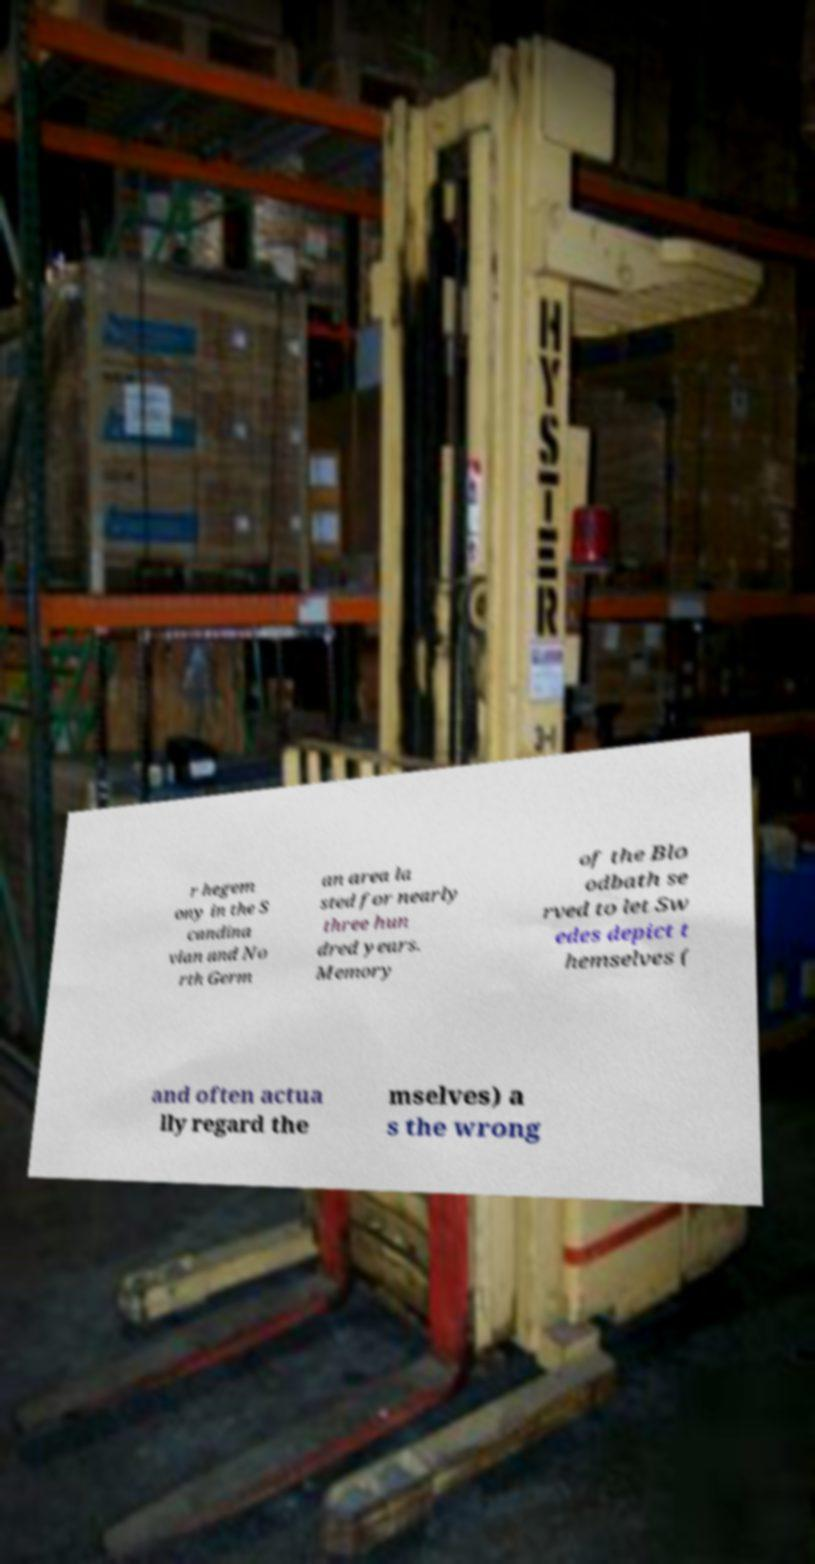Could you extract and type out the text from this image? r hegem ony in the S candina vian and No rth Germ an area la sted for nearly three hun dred years. Memory of the Blo odbath se rved to let Sw edes depict t hemselves ( and often actua lly regard the mselves) a s the wrong 